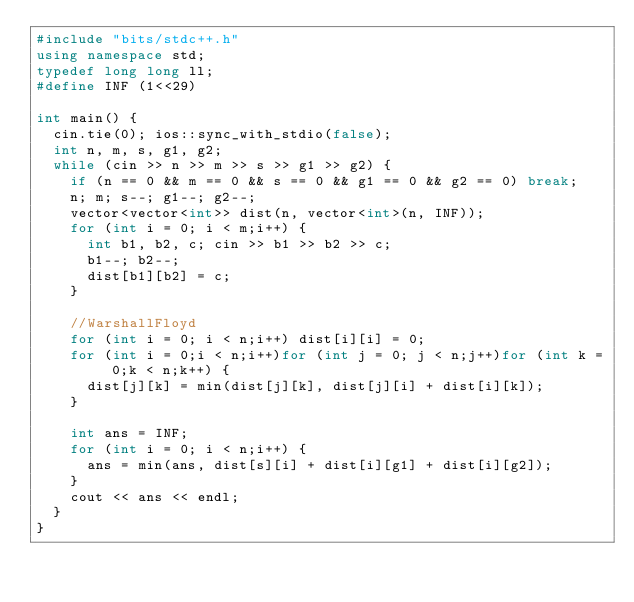<code> <loc_0><loc_0><loc_500><loc_500><_C++_>#include "bits/stdc++.h"
using namespace std;
typedef long long ll;
#define INF (1<<29)

int main() {
	cin.tie(0); ios::sync_with_stdio(false);
	int n, m, s, g1, g2;
	while (cin >> n >> m >> s >> g1 >> g2) {
		if (n == 0 && m == 0 && s == 0 && g1 == 0 && g2 == 0) break;
		n; m; s--; g1--; g2--;
		vector<vector<int>> dist(n, vector<int>(n, INF));
		for (int i = 0; i < m;i++) {
			int b1, b2, c; cin >> b1 >> b2 >> c;
			b1--; b2--;
			dist[b1][b2] = c;
		}

		//WarshallFloyd
		for (int i = 0; i < n;i++) dist[i][i] = 0;
		for (int i = 0;i < n;i++)for (int j = 0; j < n;j++)for (int k = 0;k < n;k++) {
			dist[j][k] = min(dist[j][k], dist[j][i] + dist[i][k]);
		}

		int ans = INF;
		for (int i = 0; i < n;i++) {
			ans = min(ans, dist[s][i] + dist[i][g1] + dist[i][g2]);
		}
		cout << ans << endl;
	}
}</code> 